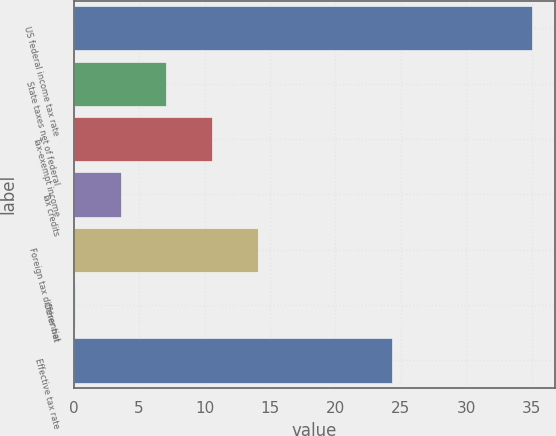Convert chart to OTSL. <chart><loc_0><loc_0><loc_500><loc_500><bar_chart><fcel>US federal income tax rate<fcel>State taxes net of federal<fcel>Tax-exempt income<fcel>Tax credits<fcel>Foreign tax differential<fcel>Other net<fcel>Effective tax rate<nl><fcel>35<fcel>7.08<fcel>10.57<fcel>3.59<fcel>14.06<fcel>0.1<fcel>24.3<nl></chart> 